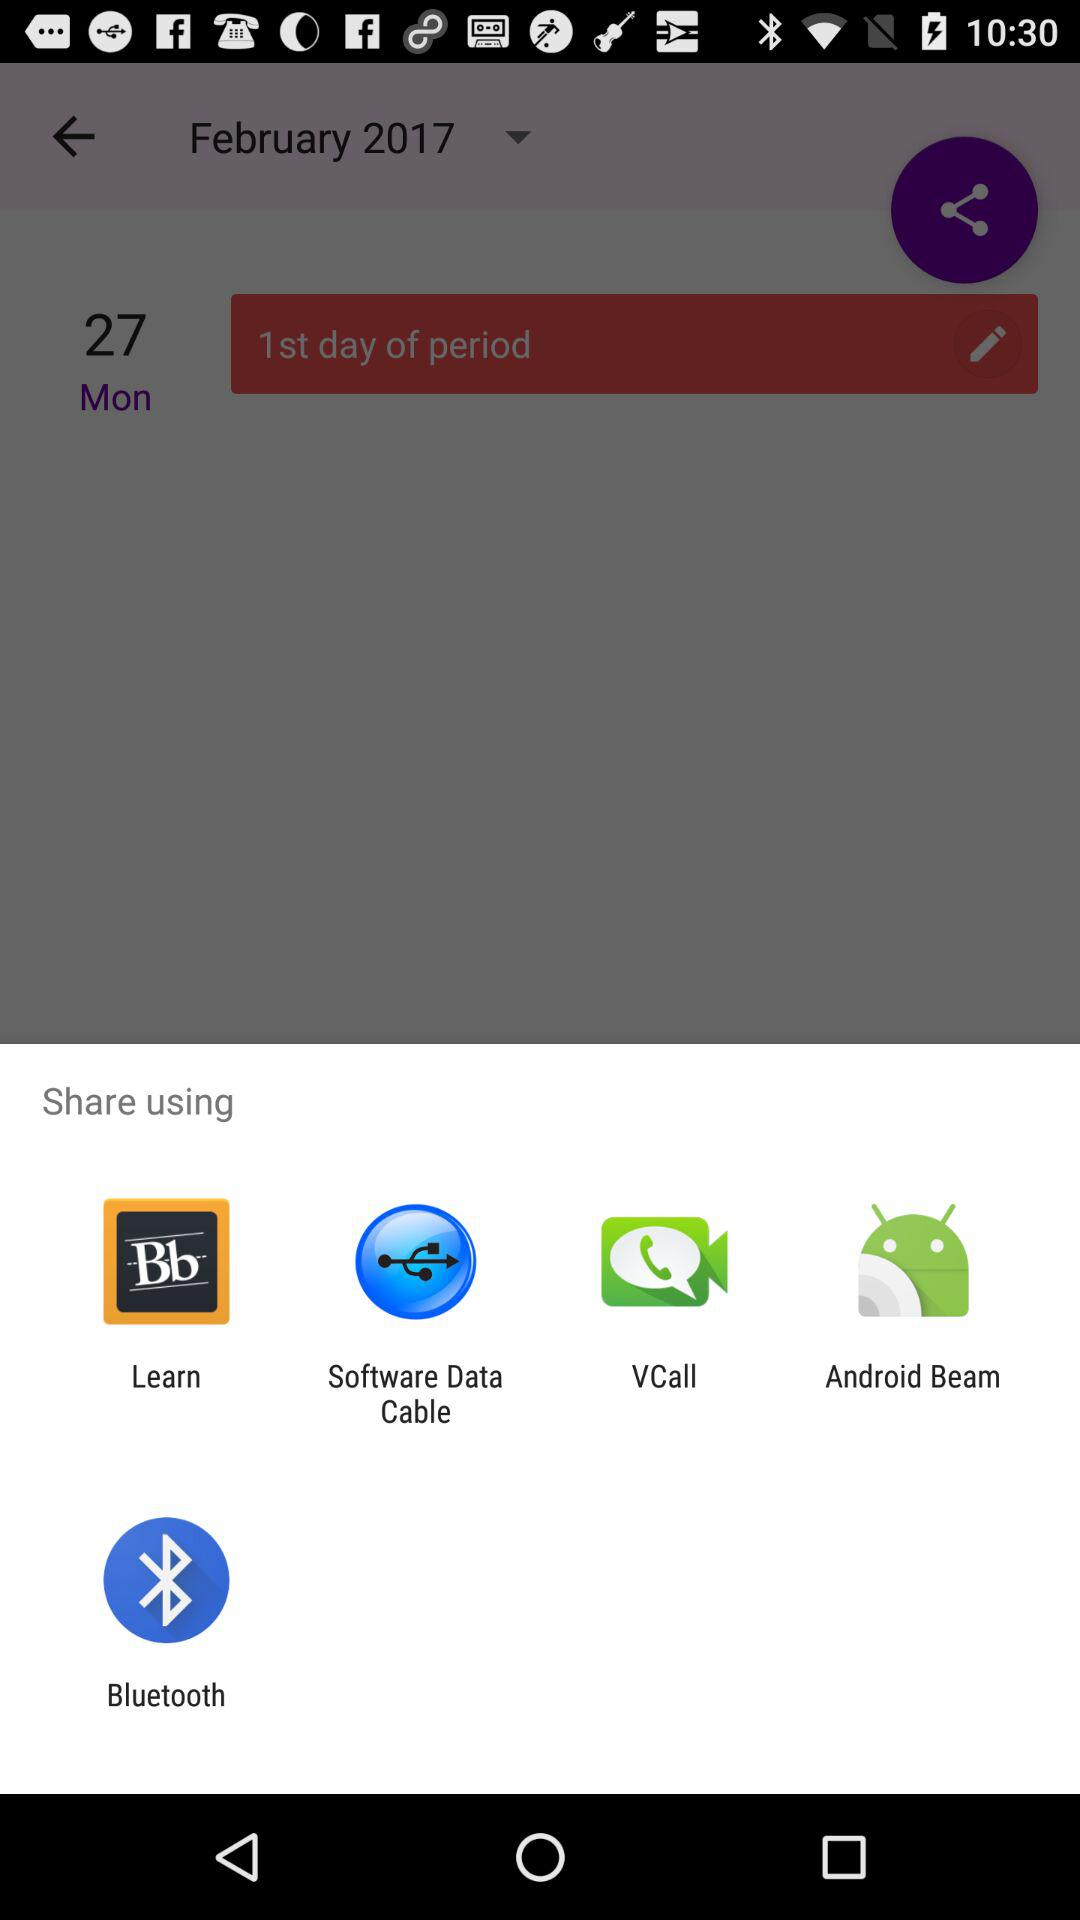When did the period start? The period started on Monday, February 27, 2017. 